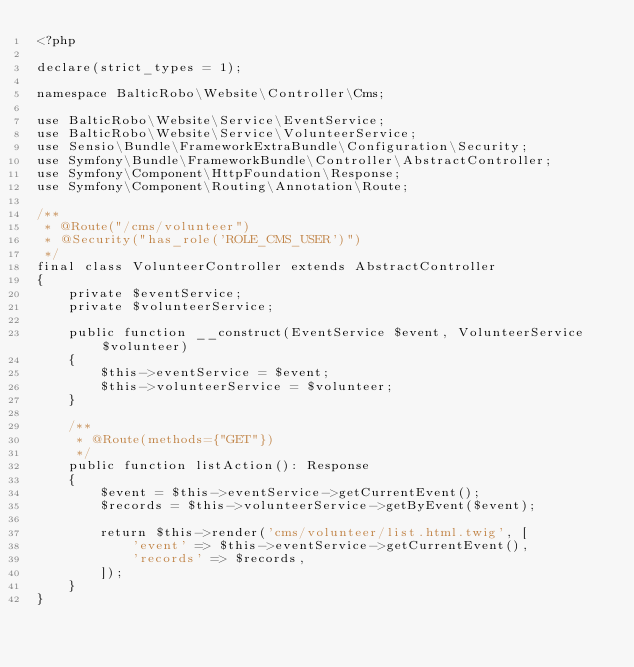Convert code to text. <code><loc_0><loc_0><loc_500><loc_500><_PHP_><?php

declare(strict_types = 1);

namespace BalticRobo\Website\Controller\Cms;

use BalticRobo\Website\Service\EventService;
use BalticRobo\Website\Service\VolunteerService;
use Sensio\Bundle\FrameworkExtraBundle\Configuration\Security;
use Symfony\Bundle\FrameworkBundle\Controller\AbstractController;
use Symfony\Component\HttpFoundation\Response;
use Symfony\Component\Routing\Annotation\Route;

/**
 * @Route("/cms/volunteer")
 * @Security("has_role('ROLE_CMS_USER')")
 */
final class VolunteerController extends AbstractController
{
    private $eventService;
    private $volunteerService;

    public function __construct(EventService $event, VolunteerService $volunteer)
    {
        $this->eventService = $event;
        $this->volunteerService = $volunteer;
    }

    /**
     * @Route(methods={"GET"})
     */
    public function listAction(): Response
    {
        $event = $this->eventService->getCurrentEvent();
        $records = $this->volunteerService->getByEvent($event);

        return $this->render('cms/volunteer/list.html.twig', [
            'event' => $this->eventService->getCurrentEvent(),
            'records' => $records,
        ]);
    }
}
</code> 